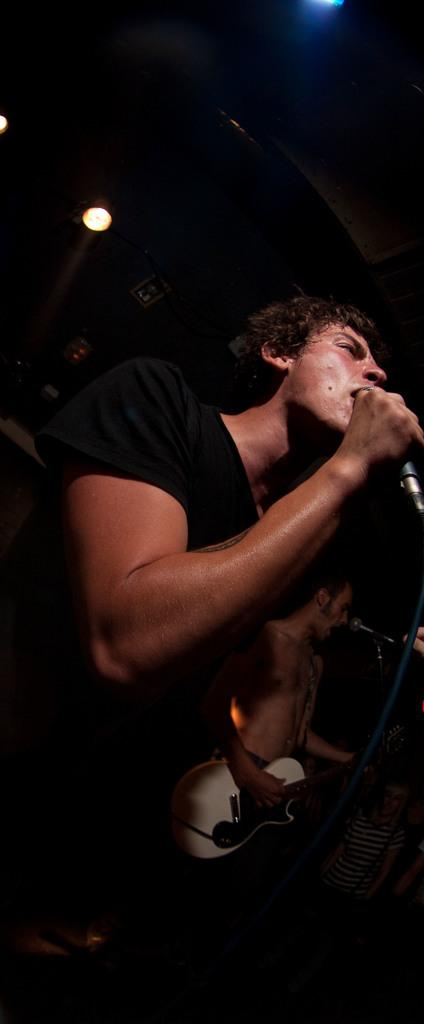What is the man in the image doing? The man is singing in the image. What object is the man holding while singing? The man is holding a microphone. Can you describe the second man in the image? The second man is in the background of the image and is playing a guitar. What type of button can be seen on the sofa in the image? There is no sofa or button present in the image. How many cars are visible in the image? There are no cars visible in the image. 